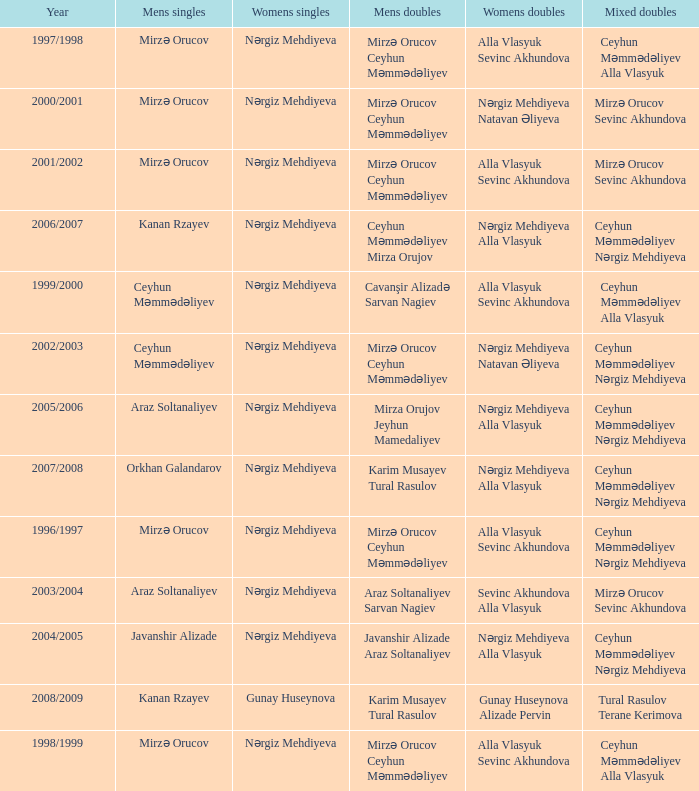What are all values for Womens Doubles in the year 2000/2001? Nərgiz Mehdiyeva Natavan Əliyeva. Parse the table in full. {'header': ['Year', 'Mens singles', 'Womens singles', 'Mens doubles', 'Womens doubles', 'Mixed doubles'], 'rows': [['1997/1998', 'Mirzə Orucov', 'Nərgiz Mehdiyeva', 'Mirzə Orucov Ceyhun Məmmədəliyev', 'Alla Vlasyuk Sevinc Akhundova', 'Ceyhun Məmmədəliyev Alla Vlasyuk'], ['2000/2001', 'Mirzə Orucov', 'Nərgiz Mehdiyeva', 'Mirzə Orucov Ceyhun Məmmədəliyev', 'Nərgiz Mehdiyeva Natavan Əliyeva', 'Mirzə Orucov Sevinc Akhundova'], ['2001/2002', 'Mirzə Orucov', 'Nərgiz Mehdiyeva', 'Mirzə Orucov Ceyhun Məmmədəliyev', 'Alla Vlasyuk Sevinc Akhundova', 'Mirzə Orucov Sevinc Akhundova'], ['2006/2007', 'Kanan Rzayev', 'Nərgiz Mehdiyeva', 'Ceyhun Məmmədəliyev Mirza Orujov', 'Nərgiz Mehdiyeva Alla Vlasyuk', 'Ceyhun Məmmədəliyev Nərgiz Mehdiyeva'], ['1999/2000', 'Ceyhun Məmmədəliyev', 'Nərgiz Mehdiyeva', 'Cavanşir Alizadə Sarvan Nagiev', 'Alla Vlasyuk Sevinc Akhundova', 'Ceyhun Məmmədəliyev Alla Vlasyuk'], ['2002/2003', 'Ceyhun Məmmədəliyev', 'Nərgiz Mehdiyeva', 'Mirzə Orucov Ceyhun Məmmədəliyev', 'Nərgiz Mehdiyeva Natavan Əliyeva', 'Ceyhun Məmmədəliyev Nərgiz Mehdiyeva'], ['2005/2006', 'Araz Soltanaliyev', 'Nərgiz Mehdiyeva', 'Mirza Orujov Jeyhun Mamedaliyev', 'Nərgiz Mehdiyeva Alla Vlasyuk', 'Ceyhun Məmmədəliyev Nərgiz Mehdiyeva'], ['2007/2008', 'Orkhan Galandarov', 'Nərgiz Mehdiyeva', 'Karim Musayev Tural Rasulov', 'Nərgiz Mehdiyeva Alla Vlasyuk', 'Ceyhun Məmmədəliyev Nərgiz Mehdiyeva'], ['1996/1997', 'Mirzə Orucov', 'Nərgiz Mehdiyeva', 'Mirzə Orucov Ceyhun Məmmədəliyev', 'Alla Vlasyuk Sevinc Akhundova', 'Ceyhun Məmmədəliyev Nərgiz Mehdiyeva'], ['2003/2004', 'Araz Soltanaliyev', 'Nərgiz Mehdiyeva', 'Araz Soltanaliyev Sarvan Nagiev', 'Sevinc Akhundova Alla Vlasyuk', 'Mirzə Orucov Sevinc Akhundova'], ['2004/2005', 'Javanshir Alizade', 'Nərgiz Mehdiyeva', 'Javanshir Alizade Araz Soltanaliyev', 'Nərgiz Mehdiyeva Alla Vlasyuk', 'Ceyhun Məmmədəliyev Nərgiz Mehdiyeva'], ['2008/2009', 'Kanan Rzayev', 'Gunay Huseynova', 'Karim Musayev Tural Rasulov', 'Gunay Huseynova Alizade Pervin', 'Tural Rasulov Terane Kerimova'], ['1998/1999', 'Mirzə Orucov', 'Nərgiz Mehdiyeva', 'Mirzə Orucov Ceyhun Məmmədəliyev', 'Alla Vlasyuk Sevinc Akhundova', 'Ceyhun Məmmədəliyev Alla Vlasyuk']]} 